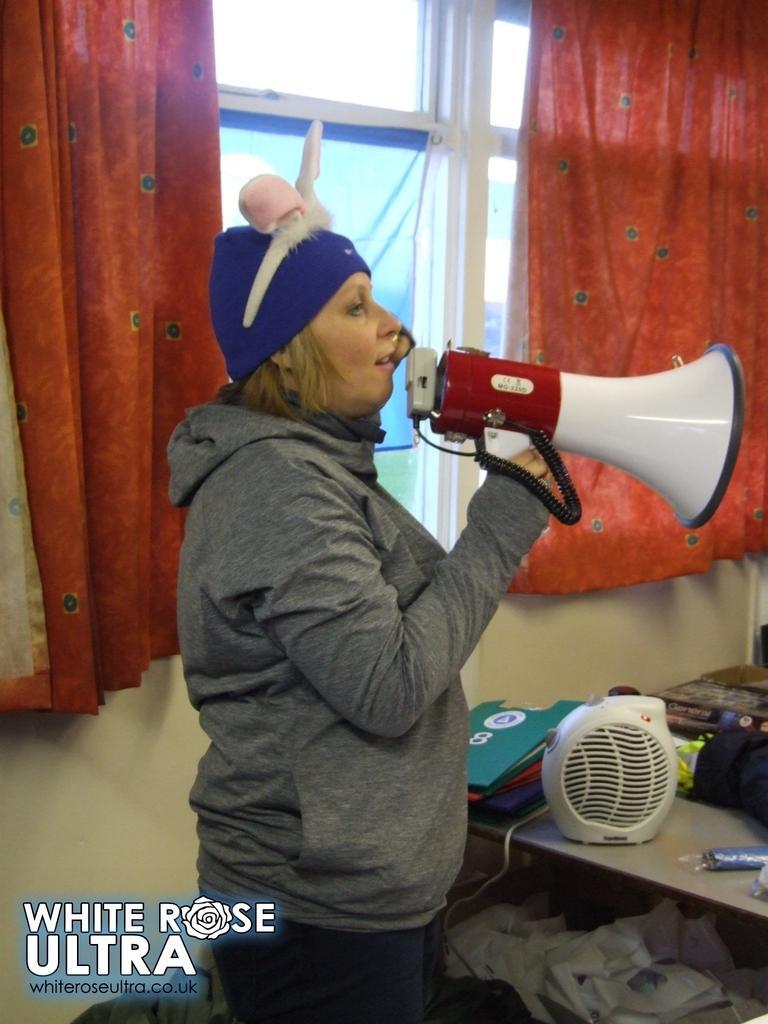Please provide a concise description of this image. The image is taken in a room. In the center of the picture there is a woman wearing a hoodie and holding a mike. On the right there is a desk, on the desk there are files, papers, fan and clothes. In the background there are windows and curtain, below the window it is a wall. On the left there is some text. 